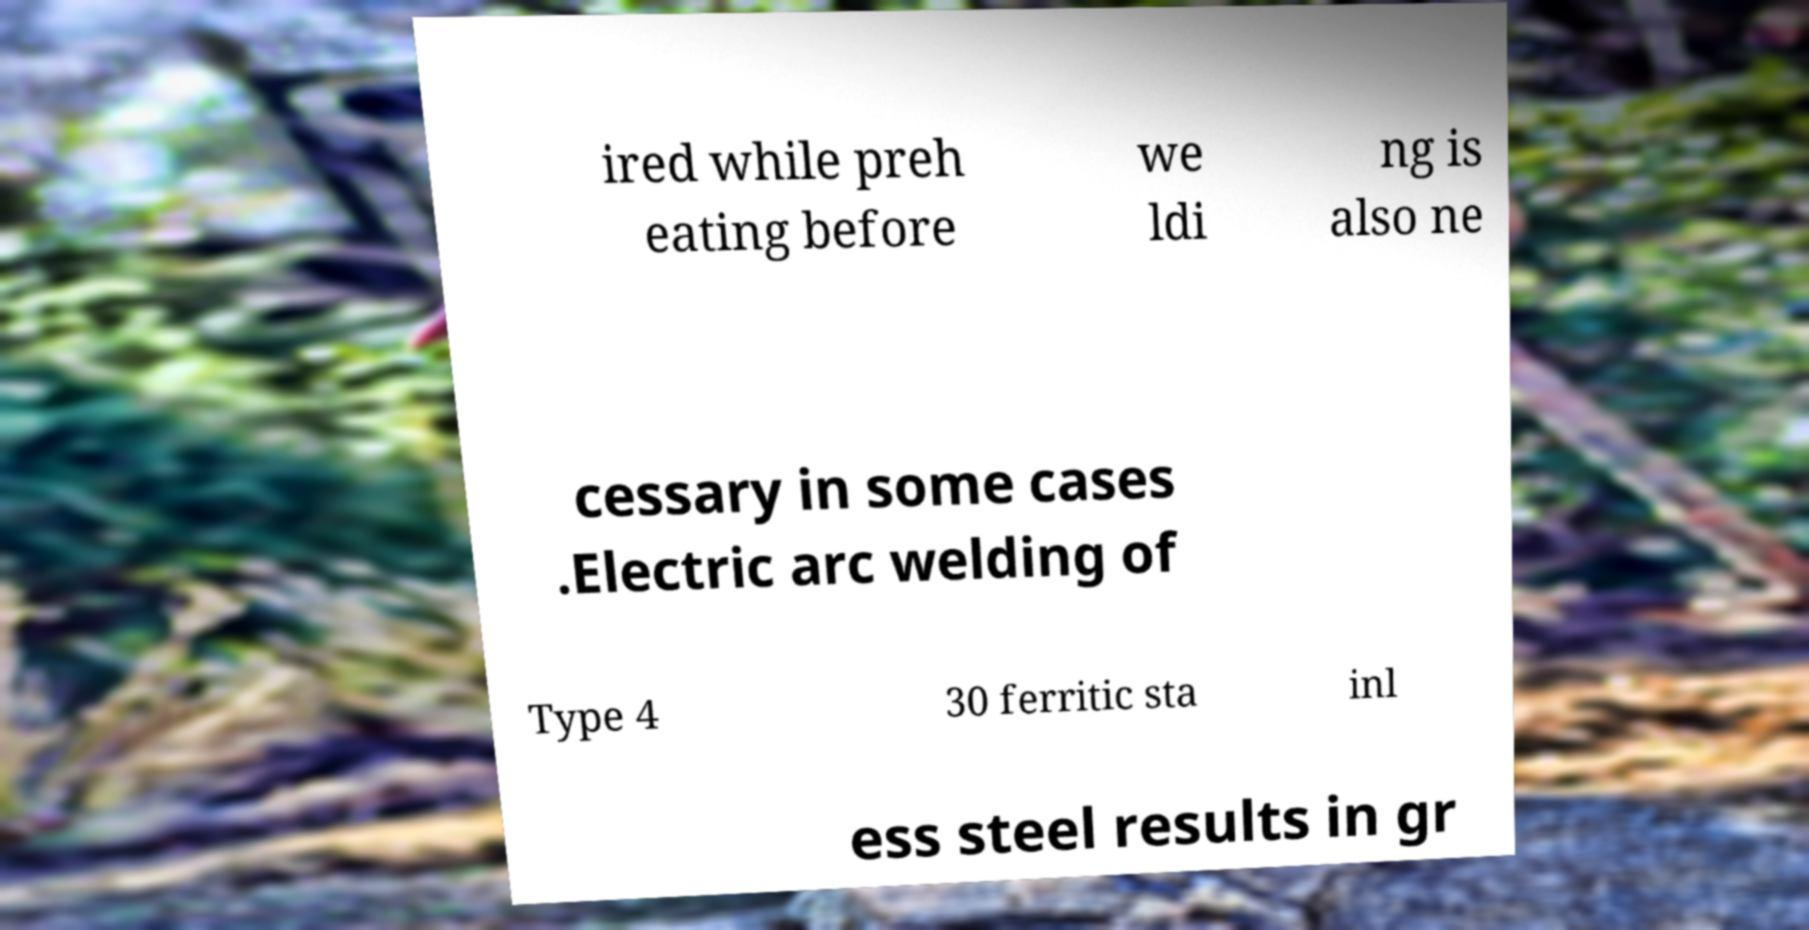I need the written content from this picture converted into text. Can you do that? ired while preh eating before we ldi ng is also ne cessary in some cases .Electric arc welding of Type 4 30 ferritic sta inl ess steel results in gr 